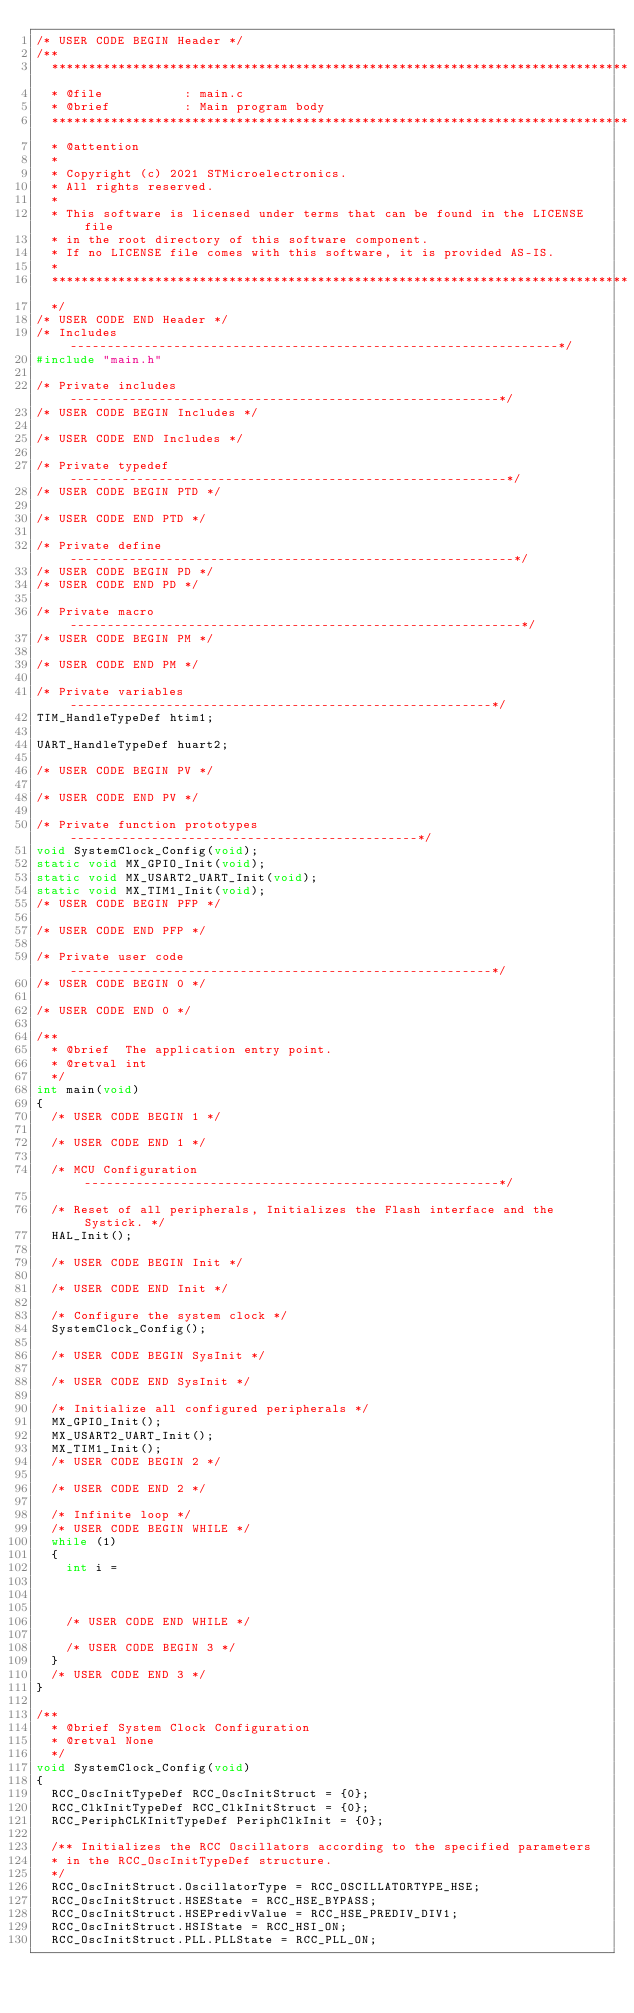Convert code to text. <code><loc_0><loc_0><loc_500><loc_500><_C_>/* USER CODE BEGIN Header */
/**
  ******************************************************************************
  * @file           : main.c
  * @brief          : Main program body
  ******************************************************************************
  * @attention
  *
  * Copyright (c) 2021 STMicroelectronics.
  * All rights reserved.
  *
  * This software is licensed under terms that can be found in the LICENSE file
  * in the root directory of this software component.
  * If no LICENSE file comes with this software, it is provided AS-IS.
  *
  ******************************************************************************
  */
/* USER CODE END Header */
/* Includes ------------------------------------------------------------------*/
#include "main.h"

/* Private includes ----------------------------------------------------------*/
/* USER CODE BEGIN Includes */

/* USER CODE END Includes */

/* Private typedef -----------------------------------------------------------*/
/* USER CODE BEGIN PTD */

/* USER CODE END PTD */

/* Private define ------------------------------------------------------------*/
/* USER CODE BEGIN PD */
/* USER CODE END PD */

/* Private macro -------------------------------------------------------------*/
/* USER CODE BEGIN PM */

/* USER CODE END PM */

/* Private variables ---------------------------------------------------------*/
TIM_HandleTypeDef htim1;

UART_HandleTypeDef huart2;

/* USER CODE BEGIN PV */

/* USER CODE END PV */

/* Private function prototypes -----------------------------------------------*/
void SystemClock_Config(void);
static void MX_GPIO_Init(void);
static void MX_USART2_UART_Init(void);
static void MX_TIM1_Init(void);
/* USER CODE BEGIN PFP */

/* USER CODE END PFP */

/* Private user code ---------------------------------------------------------*/
/* USER CODE BEGIN 0 */

/* USER CODE END 0 */

/**
  * @brief  The application entry point.
  * @retval int
  */
int main(void)
{
  /* USER CODE BEGIN 1 */

  /* USER CODE END 1 */

  /* MCU Configuration--------------------------------------------------------*/

  /* Reset of all peripherals, Initializes the Flash interface and the Systick. */
  HAL_Init();

  /* USER CODE BEGIN Init */

  /* USER CODE END Init */

  /* Configure the system clock */
  SystemClock_Config();

  /* USER CODE BEGIN SysInit */

  /* USER CODE END SysInit */

  /* Initialize all configured peripherals */
  MX_GPIO_Init();
  MX_USART2_UART_Init();
  MX_TIM1_Init();
  /* USER CODE BEGIN 2 */

  /* USER CODE END 2 */

  /* Infinite loop */
  /* USER CODE BEGIN WHILE */
  while (1)
  {
	  int i =



    /* USER CODE END WHILE */

    /* USER CODE BEGIN 3 */
  }
  /* USER CODE END 3 */
}

/**
  * @brief System Clock Configuration
  * @retval None
  */
void SystemClock_Config(void)
{
  RCC_OscInitTypeDef RCC_OscInitStruct = {0};
  RCC_ClkInitTypeDef RCC_ClkInitStruct = {0};
  RCC_PeriphCLKInitTypeDef PeriphClkInit = {0};

  /** Initializes the RCC Oscillators according to the specified parameters
  * in the RCC_OscInitTypeDef structure.
  */
  RCC_OscInitStruct.OscillatorType = RCC_OSCILLATORTYPE_HSE;
  RCC_OscInitStruct.HSEState = RCC_HSE_BYPASS;
  RCC_OscInitStruct.HSEPredivValue = RCC_HSE_PREDIV_DIV1;
  RCC_OscInitStruct.HSIState = RCC_HSI_ON;
  RCC_OscInitStruct.PLL.PLLState = RCC_PLL_ON;</code> 